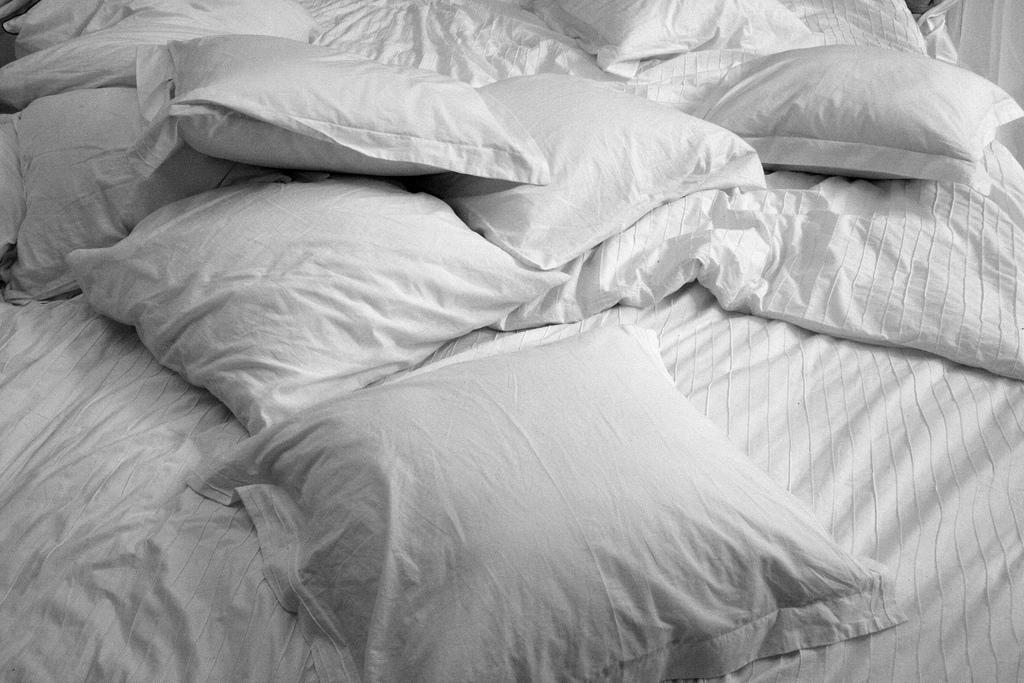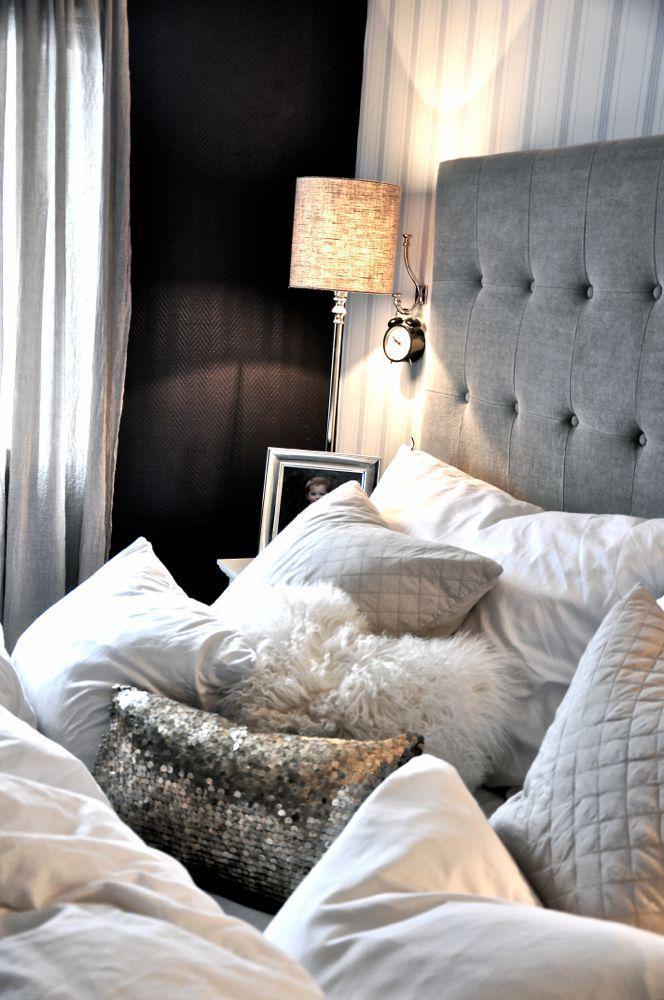The first image is the image on the left, the second image is the image on the right. For the images displayed, is the sentence "there is a table lamp on the right image" factually correct? Answer yes or no. Yes. 